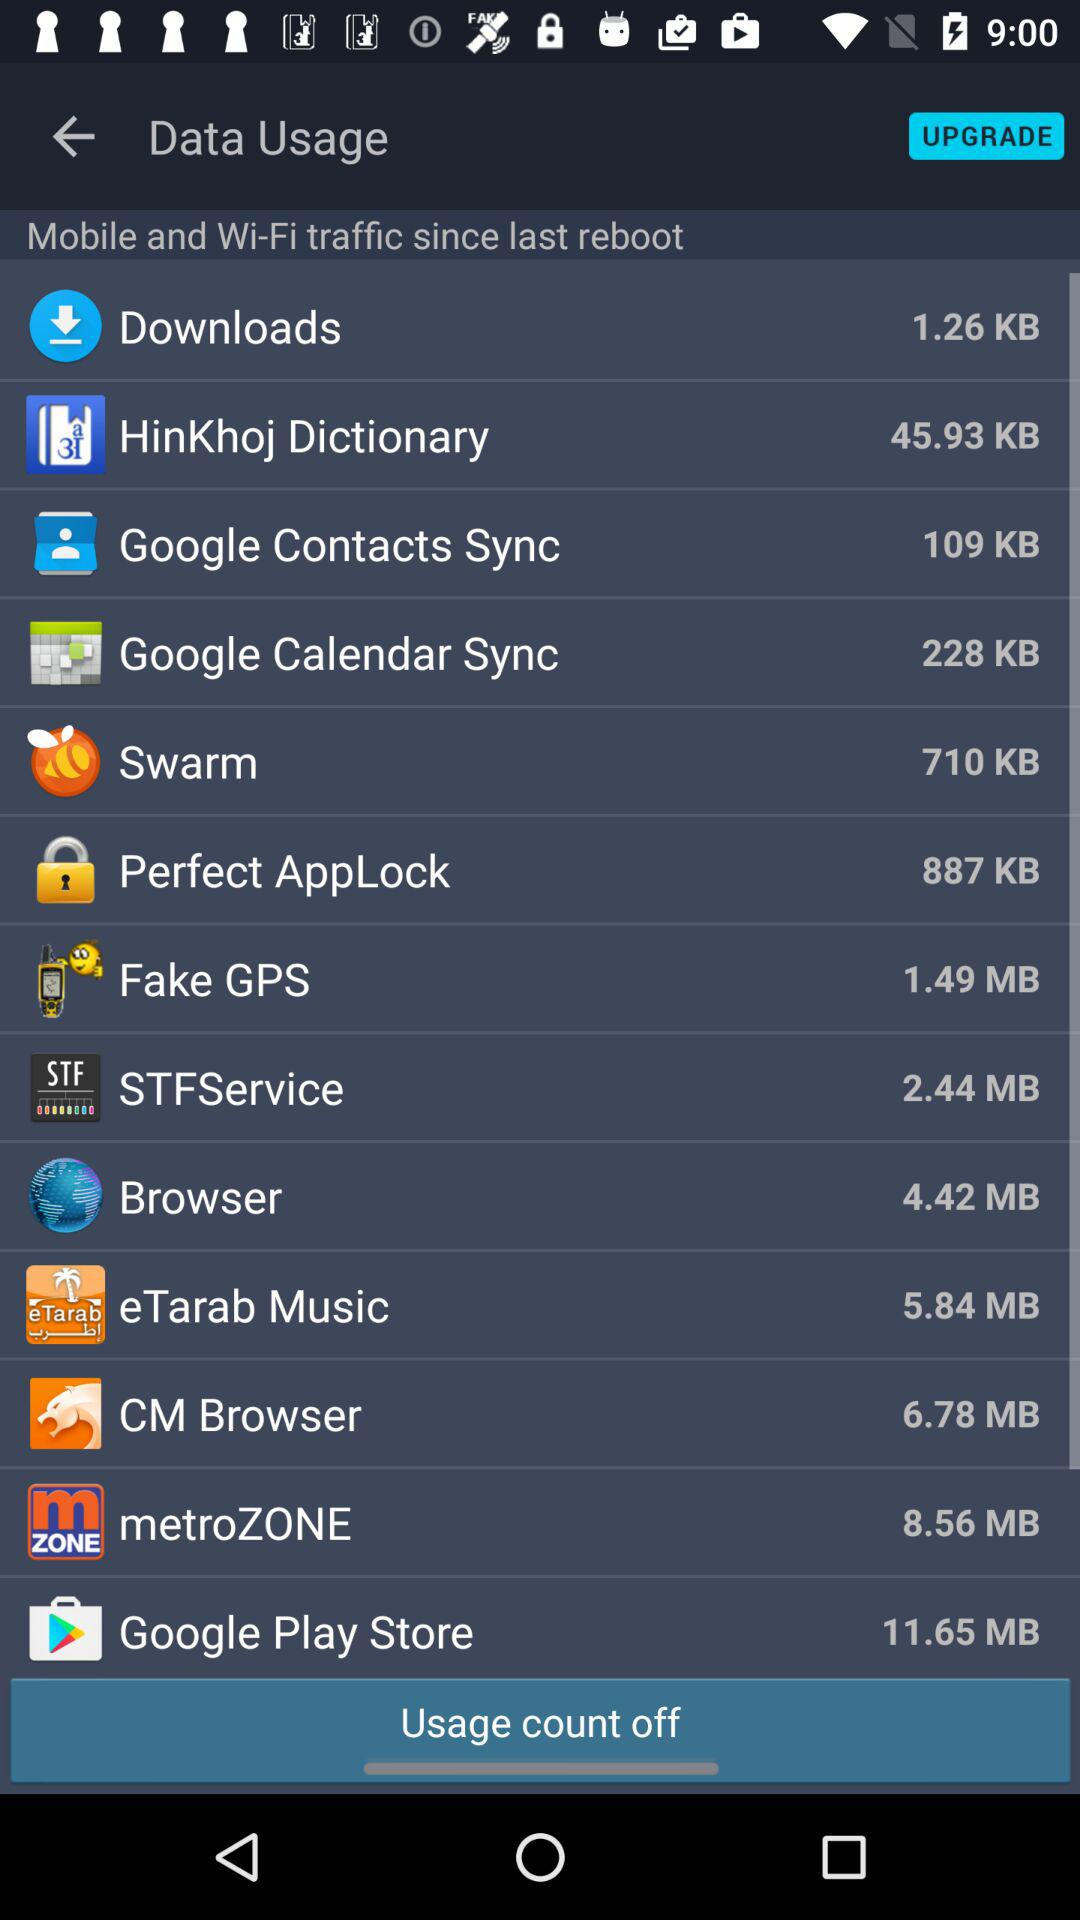Which app has used the most data: Fake GPS or Google Play Store?
Answer the question using a single word or phrase. Google Play Store 